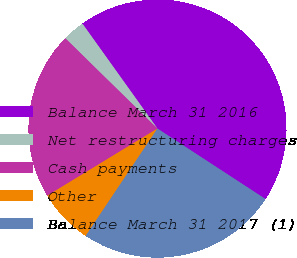Convert chart. <chart><loc_0><loc_0><loc_500><loc_500><pie_chart><fcel>Balance March 31 2016<fcel>Net restructuring charges<fcel>Cash payments<fcel>Other<fcel>Balance March 31 2017 (1)<nl><fcel>44.08%<fcel>2.78%<fcel>21.05%<fcel>6.91%<fcel>25.18%<nl></chart> 